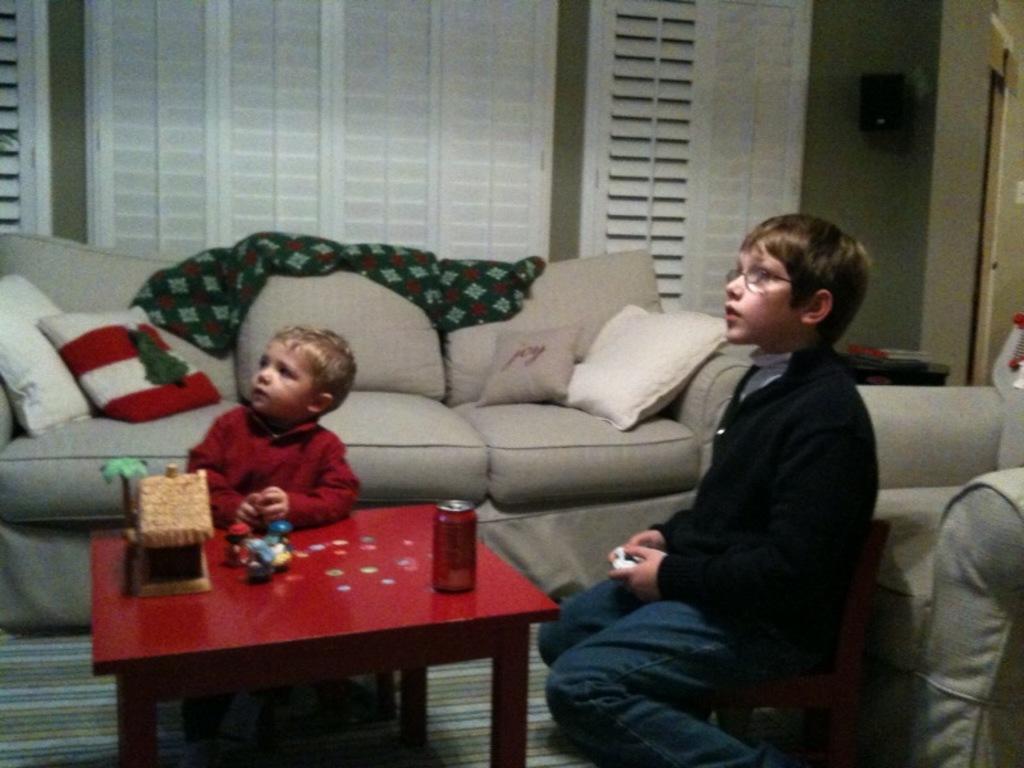Please provide a concise description of this image. Two boys are sitting at a table looking aside with a sofa in the background. 